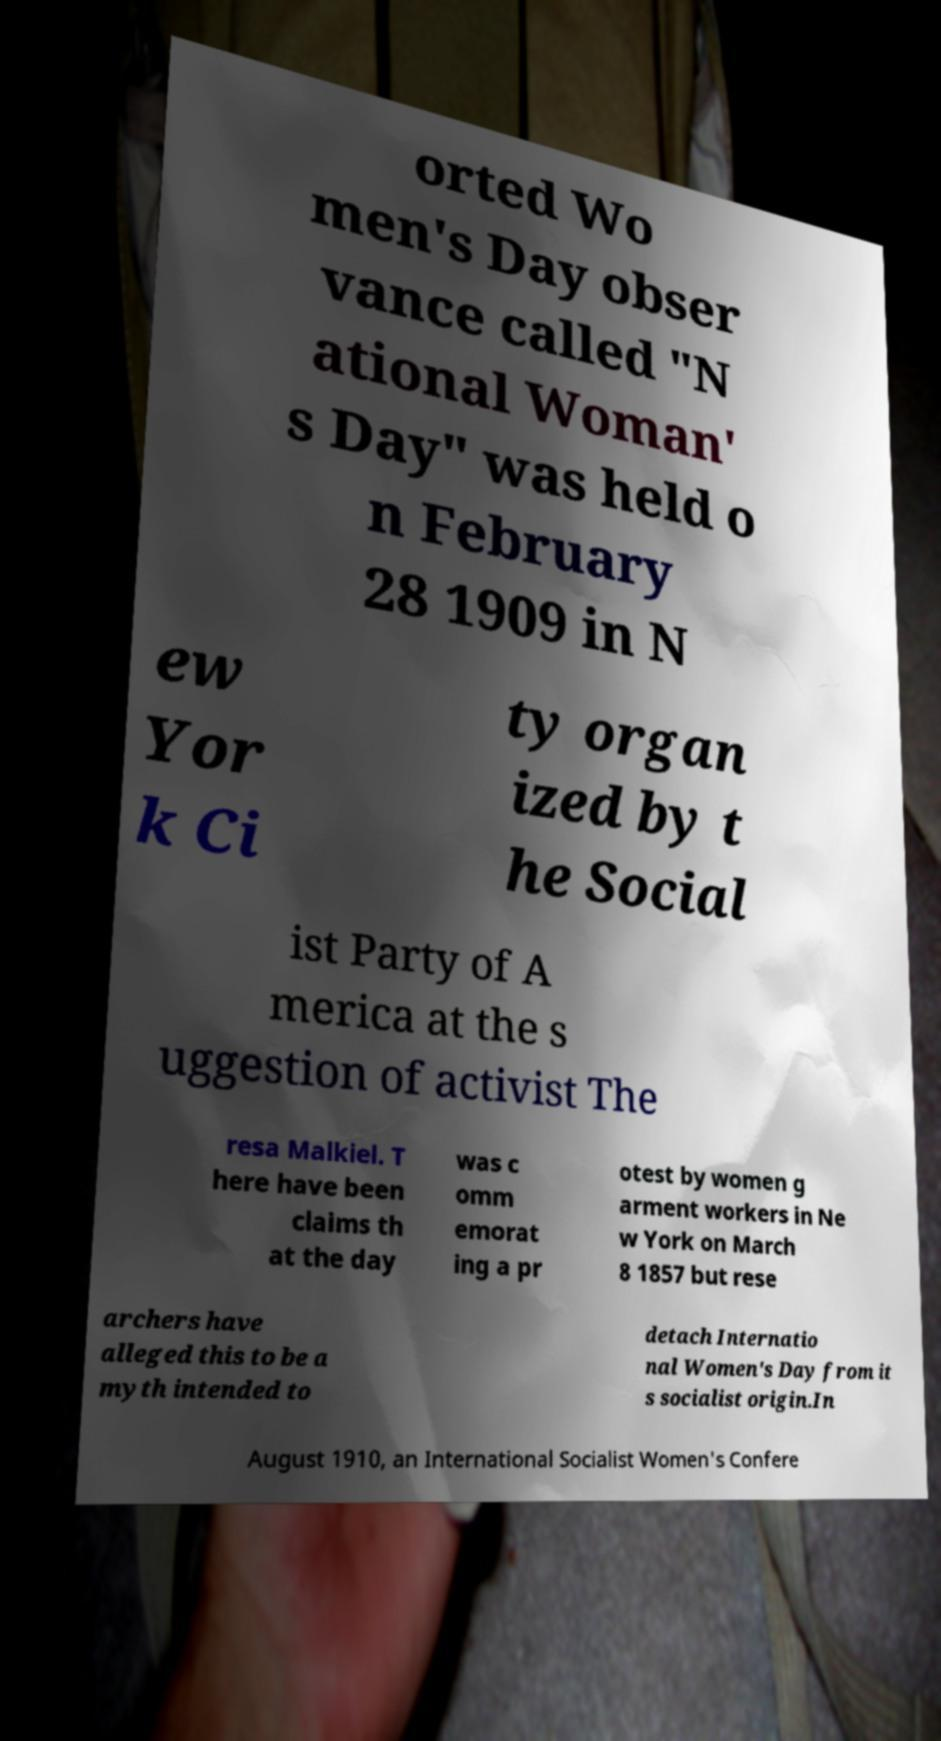For documentation purposes, I need the text within this image transcribed. Could you provide that? orted Wo men's Day obser vance called "N ational Woman' s Day" was held o n February 28 1909 in N ew Yor k Ci ty organ ized by t he Social ist Party of A merica at the s uggestion of activist The resa Malkiel. T here have been claims th at the day was c omm emorat ing a pr otest by women g arment workers in Ne w York on March 8 1857 but rese archers have alleged this to be a myth intended to detach Internatio nal Women's Day from it s socialist origin.In August 1910, an International Socialist Women's Confere 